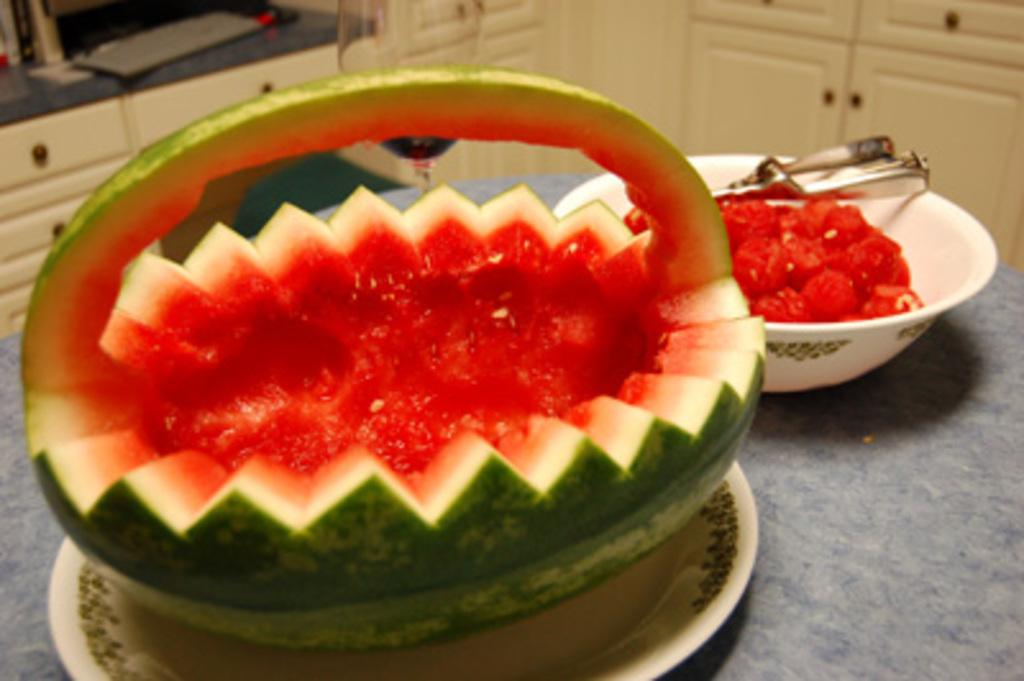What is placed on the platform in the image? There is a plate on the platform. What is on the plate? There is a watermelon on the plate. What is in the bowl next to the plate? There is a bowl containing watermelon scoops. What is used to scoop the watermelon? There is a serving scoop in the bowl. What can be seen in the background of the image? There are cupboards in the background. Is there a bomb hidden in the cupboards in the background of the image? There is no mention of a bomb in the image, and it cannot be determined from the provided facts. Is there a servant preparing the watermelon in the image? There is no indication of a servant or anyone preparing the watermelon in the image. 